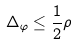Convert formula to latex. <formula><loc_0><loc_0><loc_500><loc_500>\Delta _ { \varphi } \leq \frac { 1 } { 2 } \rho</formula> 